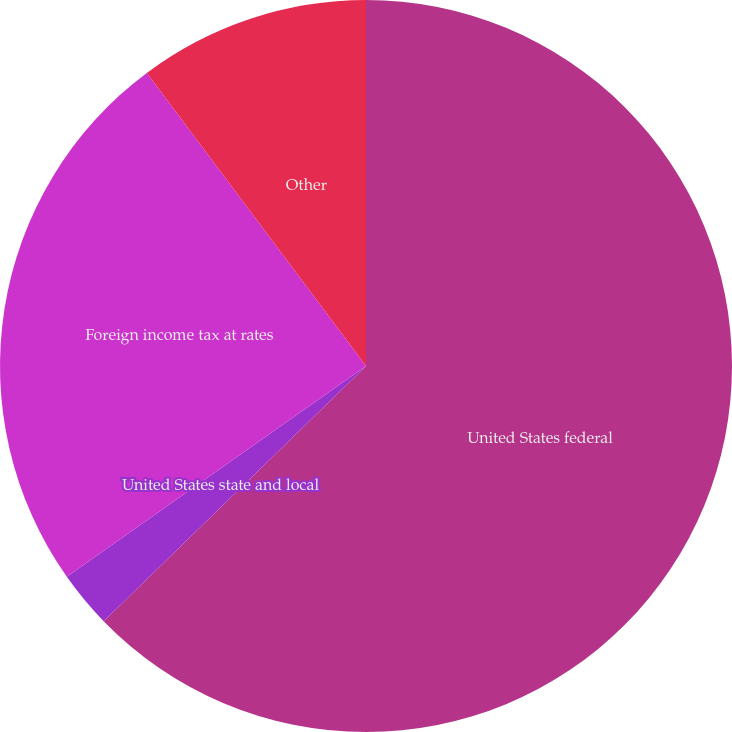Convert chart to OTSL. <chart><loc_0><loc_0><loc_500><loc_500><pie_chart><fcel>United States federal<fcel>United States state and local<fcel>Foreign income tax at rates<fcel>Other<nl><fcel>62.72%<fcel>2.51%<fcel>24.55%<fcel>10.22%<nl></chart> 